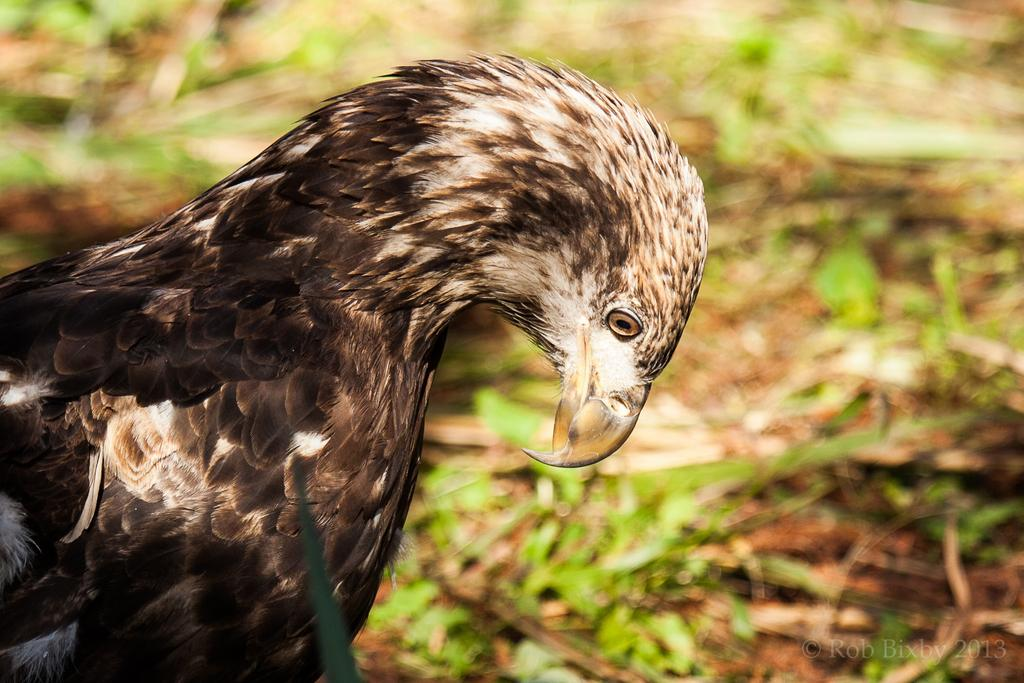What type of animal can be seen in the image? There is a bird in the image. What type of vegetation is visible in the image? There is grass visible in the image. Can you describe the background of the image? The background of the image is blurred. What type of nose does the secretary have in the image? There is no secretary present in the image, so it is not possible to determine the type of nose they might have. 